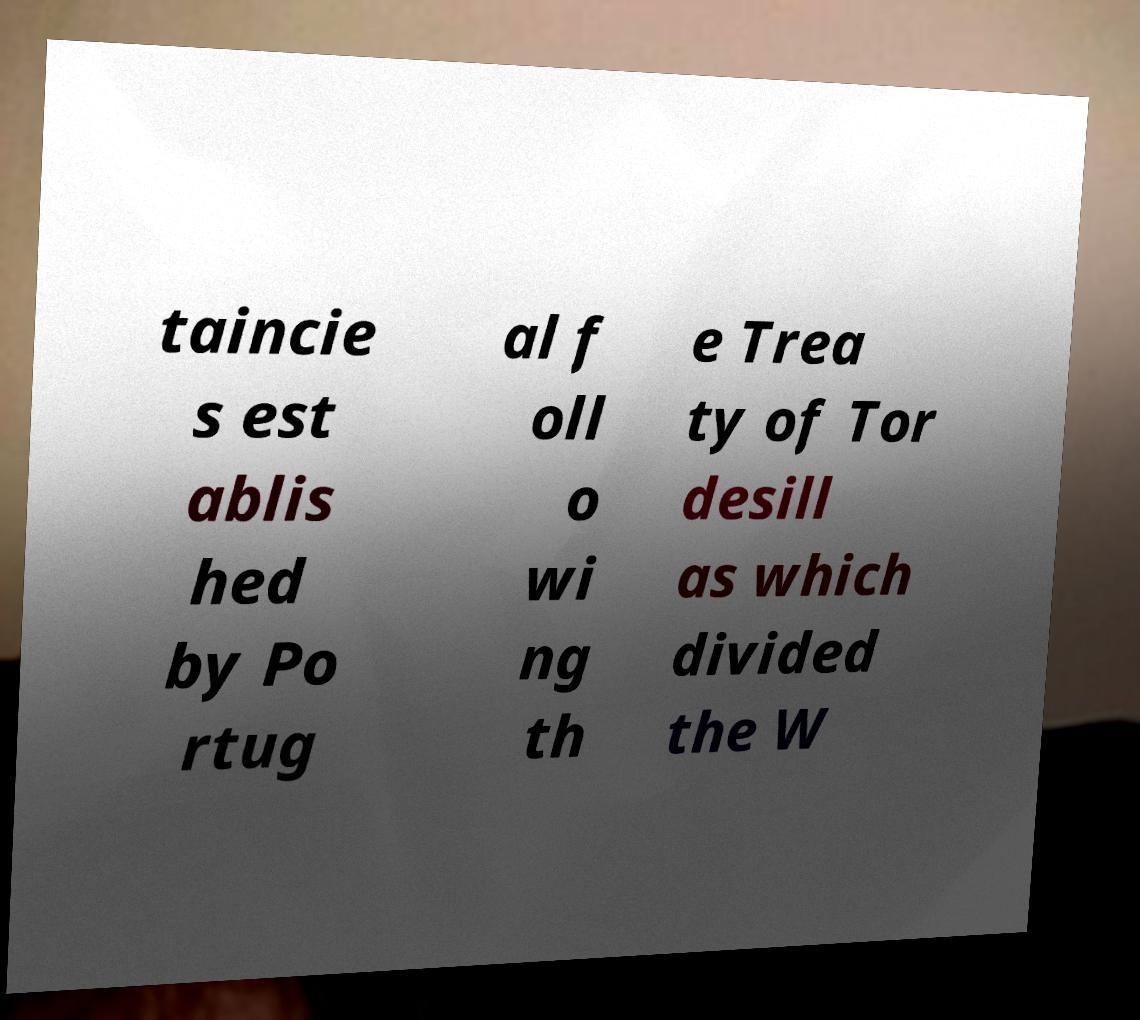There's text embedded in this image that I need extracted. Can you transcribe it verbatim? taincie s est ablis hed by Po rtug al f oll o wi ng th e Trea ty of Tor desill as which divided the W 